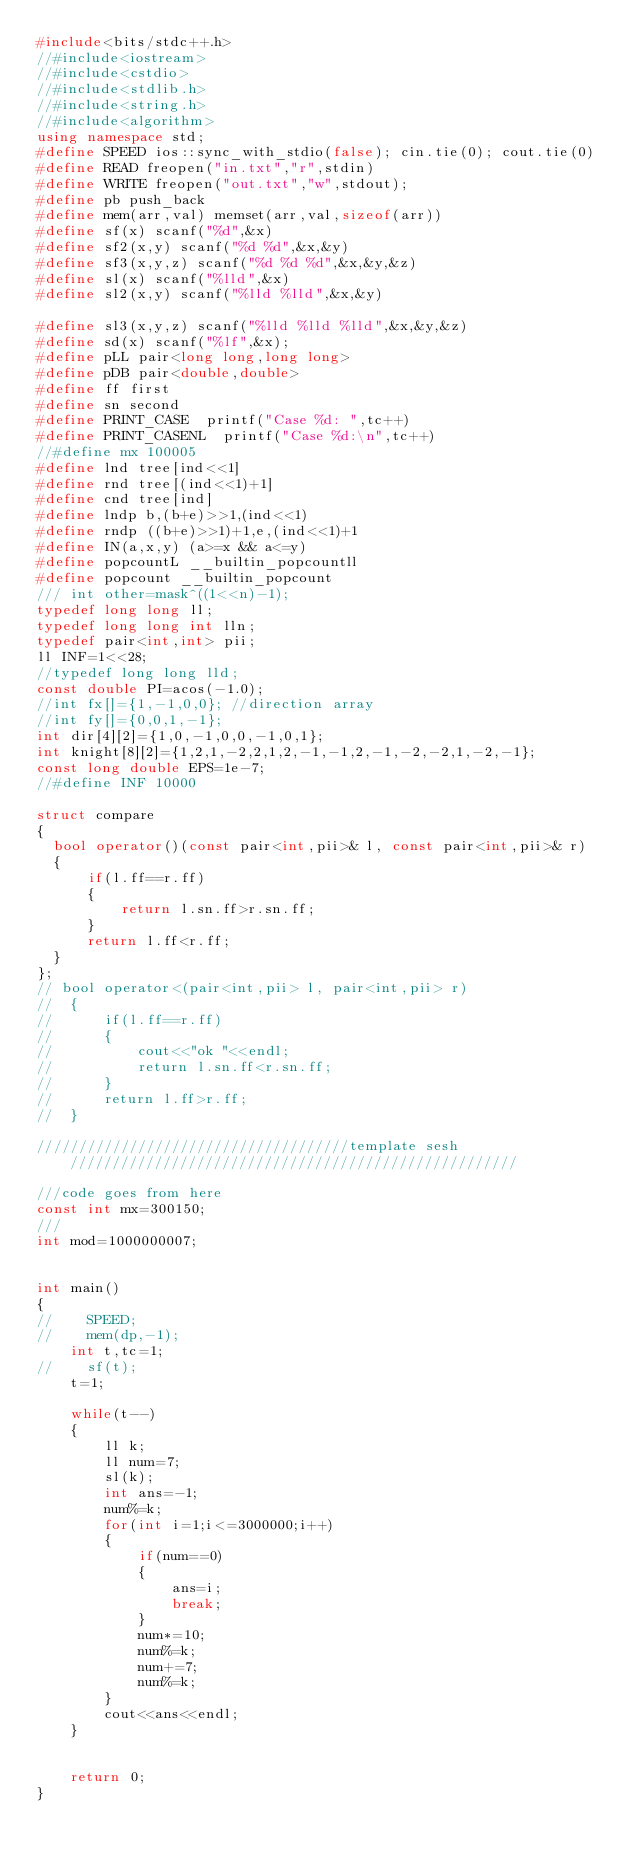Convert code to text. <code><loc_0><loc_0><loc_500><loc_500><_C++_>#include<bits/stdc++.h>
//#include<iostream>
//#include<cstdio>
//#include<stdlib.h>
//#include<string.h>
//#include<algorithm>
using namespace std;
#define SPEED ios::sync_with_stdio(false); cin.tie(0); cout.tie(0)
#define READ freopen("in.txt","r",stdin)
#define WRITE freopen("out.txt","w",stdout);
#define pb push_back
#define mem(arr,val) memset(arr,val,sizeof(arr))
#define sf(x) scanf("%d",&x)
#define sf2(x,y) scanf("%d %d",&x,&y)
#define sf3(x,y,z) scanf("%d %d %d",&x,&y,&z)
#define sl(x) scanf("%lld",&x)
#define sl2(x,y) scanf("%lld %lld",&x,&y)

#define sl3(x,y,z) scanf("%lld %lld %lld",&x,&y,&z)
#define sd(x) scanf("%lf",&x);
#define pLL pair<long long,long long>
#define pDB pair<double,double>
#define ff first
#define sn second
#define PRINT_CASE  printf("Case %d: ",tc++)
#define PRINT_CASENL  printf("Case %d:\n",tc++)
//#define mx 100005
#define lnd tree[ind<<1]
#define rnd tree[(ind<<1)+1]
#define cnd tree[ind]
#define lndp b,(b+e)>>1,(ind<<1)
#define rndp ((b+e)>>1)+1,e,(ind<<1)+1
#define IN(a,x,y) (a>=x && a<=y)
#define popcountL __builtin_popcountll
#define popcount __builtin_popcount
/// int other=mask^((1<<n)-1);
typedef long long ll;
typedef long long int lln;
typedef pair<int,int> pii;
ll INF=1<<28;
//typedef long long lld;
const double PI=acos(-1.0);
//int fx[]={1,-1,0,0}; //direction array
//int fy[]={0,0,1,-1};
int dir[4][2]={1,0,-1,0,0,-1,0,1};
int knight[8][2]={1,2,1,-2,2,1,2,-1,-1,2,-1,-2,-2,1,-2,-1};
const long double EPS=1e-7;
//#define INF 10000

struct compare
{
  bool operator()(const pair<int,pii>& l, const pair<int,pii>& r)
  {
      if(l.ff==r.ff)
      {
          return l.sn.ff>r.sn.ff;
      }
      return l.ff<r.ff;
  }
};
// bool operator<(pair<int,pii> l, pair<int,pii> r)
//  {
//      if(l.ff==r.ff)
//      {
//          cout<<"ok "<<endl;
//          return l.sn.ff<r.sn.ff;
//      }
//      return l.ff>r.ff;
//  }

/////////////////////////////////////template sesh/////////////////////////////////////////////////////

///code goes from here
const int mx=300150;
///
int mod=1000000007;


int main()
{
//    SPEED;
//    mem(dp,-1);
    int t,tc=1;
//    sf(t);
    t=1;

    while(t--)
    {
        ll k;
        ll num=7;
        sl(k);
        int ans=-1;
        num%=k;
        for(int i=1;i<=3000000;i++)
        {
            if(num==0)
            {
                ans=i;
                break;
            }
            num*=10;
            num%=k;
            num+=7;
            num%=k;
        }
        cout<<ans<<endl;
    }


    return 0;
}

</code> 